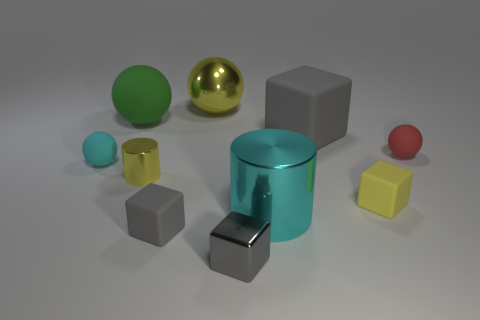Subtract all green spheres. How many gray blocks are left? 3 Subtract all yellow cubes. How many cubes are left? 3 Subtract 1 cubes. How many cubes are left? 3 Subtract all yellow blocks. How many blocks are left? 3 Subtract all yellow blocks. Subtract all gray spheres. How many blocks are left? 3 Add 6 big metal things. How many big metal things are left? 8 Add 3 large gray metal blocks. How many large gray metal blocks exist? 3 Subtract 0 cyan blocks. How many objects are left? 10 Subtract all spheres. How many objects are left? 6 Subtract all big gray rubber blocks. Subtract all red objects. How many objects are left? 8 